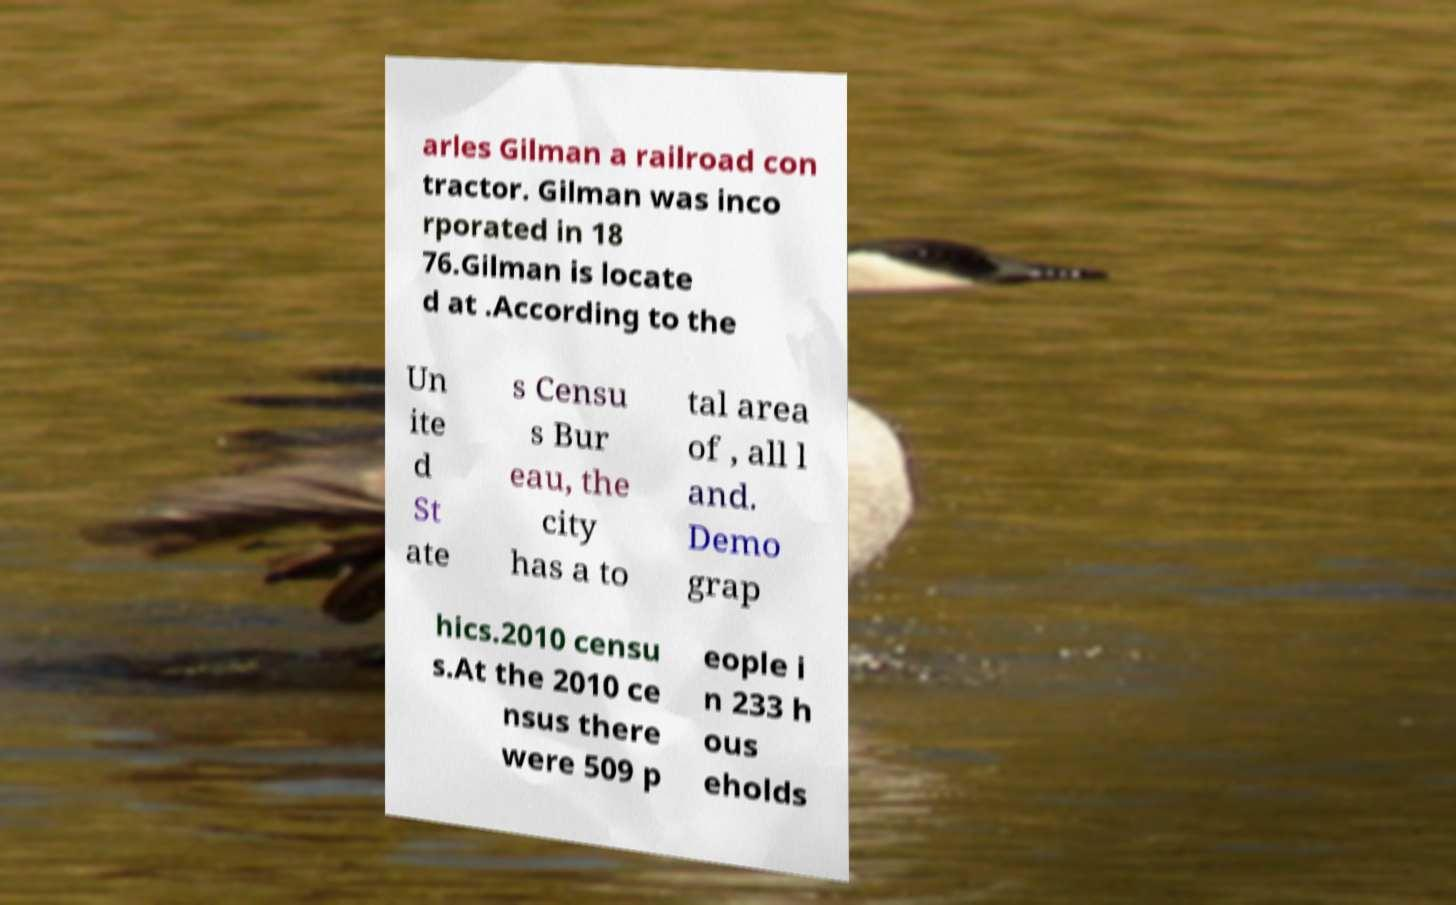Can you read and provide the text displayed in the image?This photo seems to have some interesting text. Can you extract and type it out for me? arles Gilman a railroad con tractor. Gilman was inco rporated in 18 76.Gilman is locate d at .According to the Un ite d St ate s Censu s Bur eau, the city has a to tal area of , all l and. Demo grap hics.2010 censu s.At the 2010 ce nsus there were 509 p eople i n 233 h ous eholds 